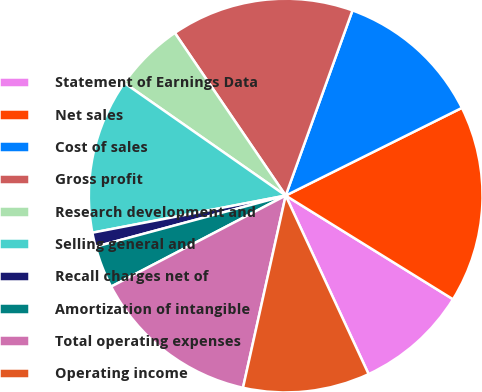Convert chart to OTSL. <chart><loc_0><loc_0><loc_500><loc_500><pie_chart><fcel>Statement of Earnings Data<fcel>Net sales<fcel>Cost of sales<fcel>Gross profit<fcel>Research development and<fcel>Selling general and<fcel>Recall charges net of<fcel>Amortization of intangible<fcel>Total operating expenses<fcel>Operating income<nl><fcel>9.25%<fcel>16.18%<fcel>12.14%<fcel>15.03%<fcel>5.78%<fcel>12.72%<fcel>1.16%<fcel>3.47%<fcel>13.87%<fcel>10.4%<nl></chart> 